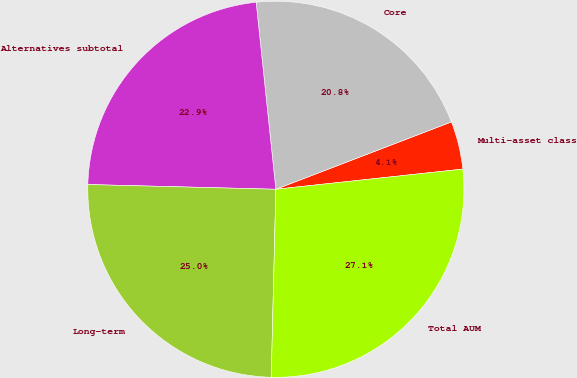Convert chart. <chart><loc_0><loc_0><loc_500><loc_500><pie_chart><fcel>Multi-asset class<fcel>Core<fcel>Alternatives subtotal<fcel>Long-term<fcel>Total AUM<nl><fcel>4.12%<fcel>20.84%<fcel>22.93%<fcel>25.01%<fcel>27.1%<nl></chart> 